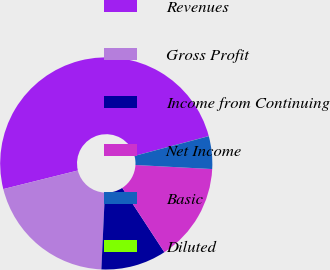Convert chart to OTSL. <chart><loc_0><loc_0><loc_500><loc_500><pie_chart><fcel>Revenues<fcel>Gross Profit<fcel>Income from Continuing<fcel>Net Income<fcel>Basic<fcel>Diluted<nl><fcel>49.74%<fcel>20.38%<fcel>9.96%<fcel>14.93%<fcel>4.98%<fcel>0.01%<nl></chart> 